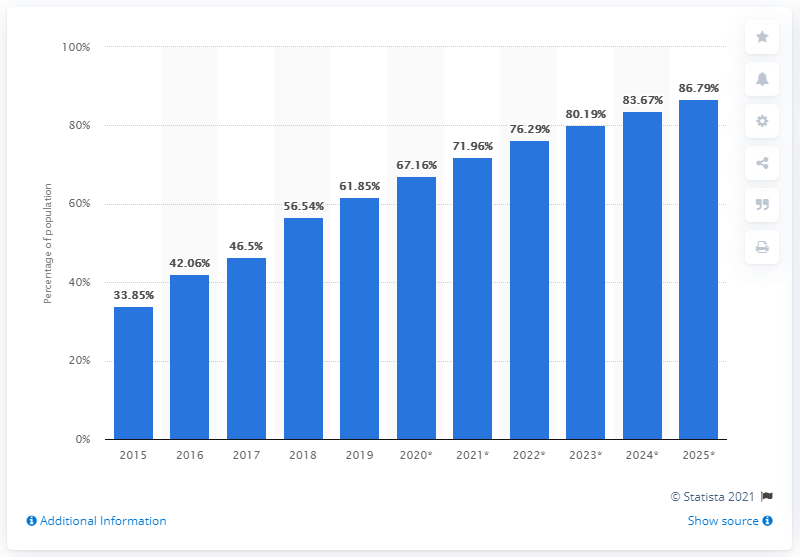Draw attention to some important aspects in this diagram. In 2019, approximately 61.85% of Indonesia's population accessed the internet from their mobile phones. 